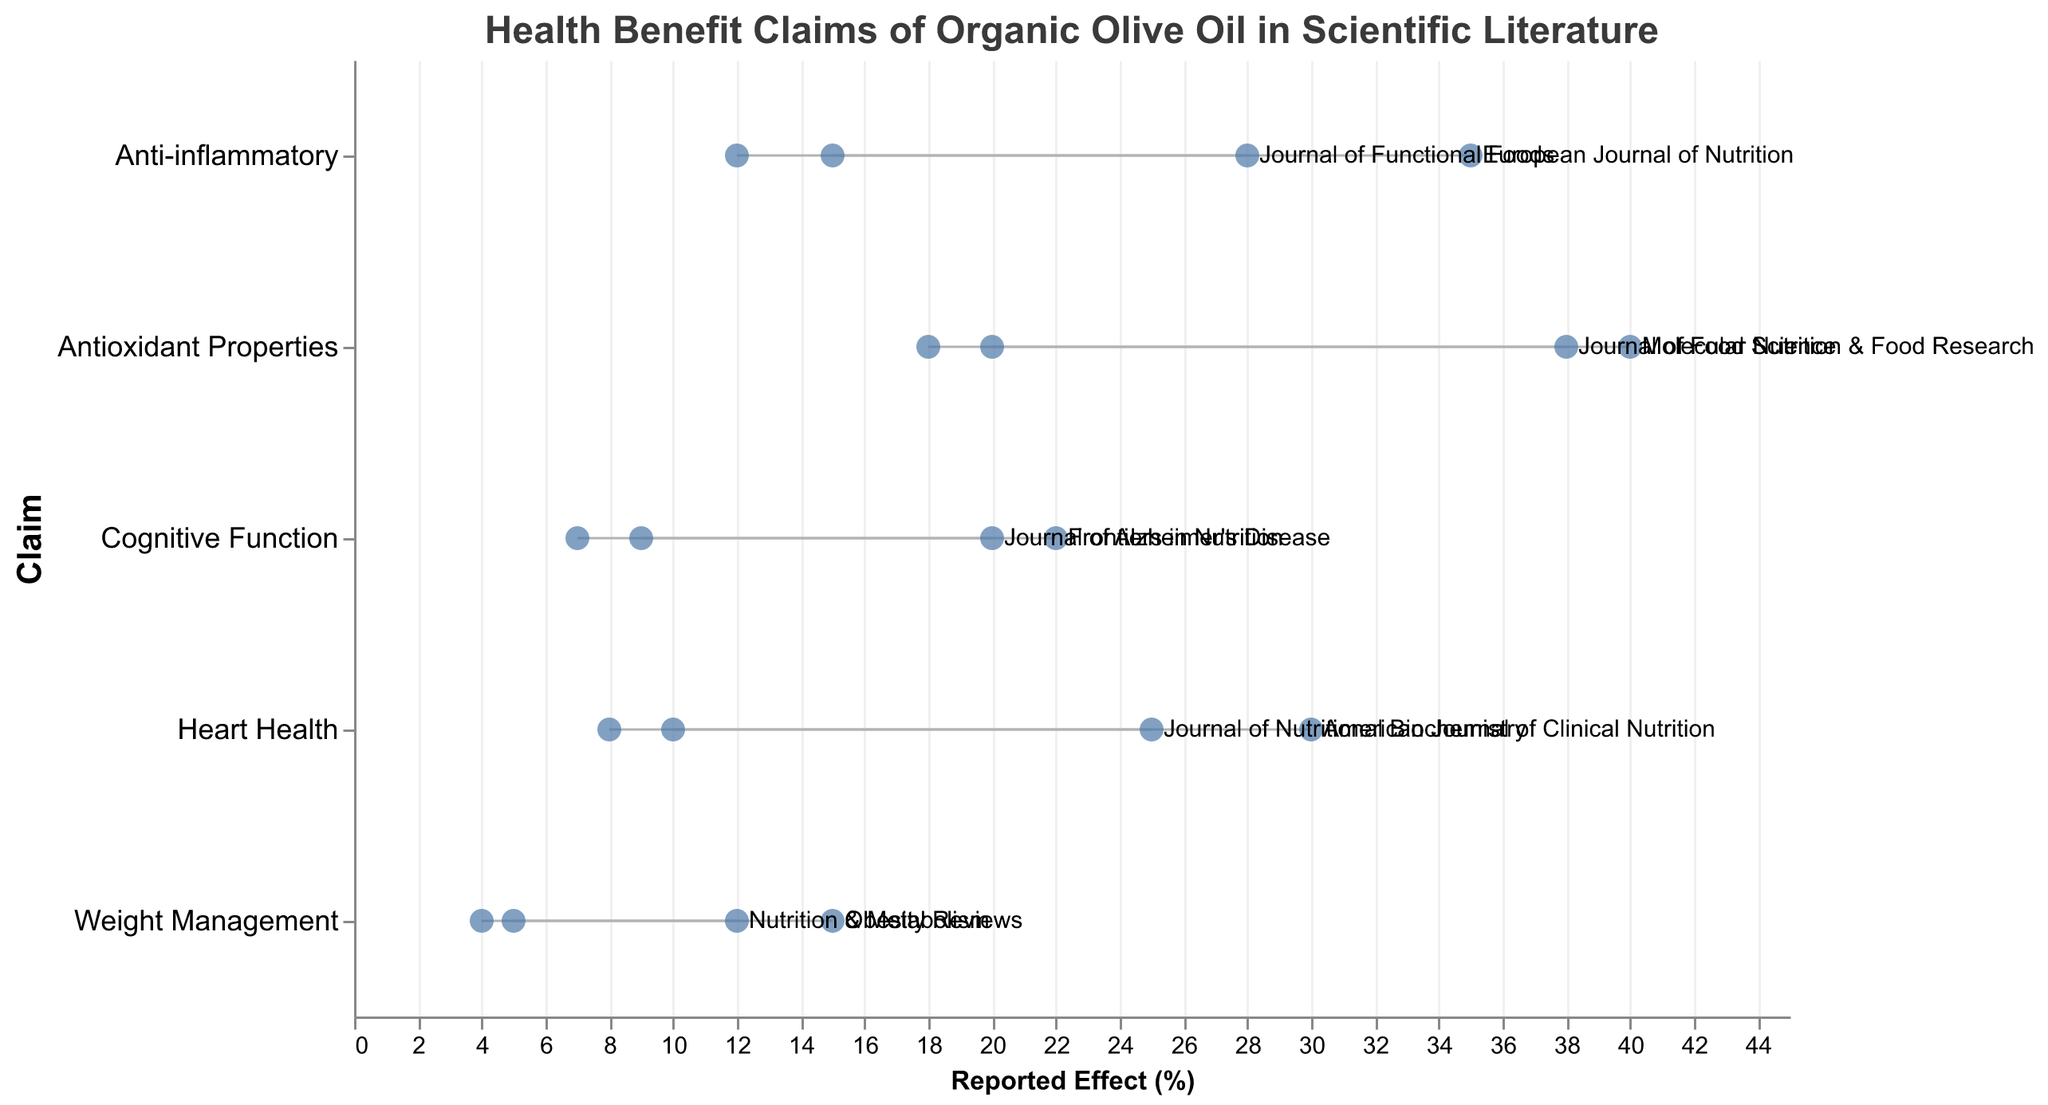What is the range of the reported effect for Heart Health in the Journal of Nutritional Biochemistry? The range can be found by looking at the minimum and maximum reported effects for Heart Health in the Journal of Nutritional Biochemistry. The min effect is 10% and the max effect is 25%.
Answer: 10%-25% Which claim shows the highest maximum reported effect? To identify the claim with the highest maximum reported effect, we need to check the maximum percentages for all claims. The highest max effect is 40% for Antioxidant Properties in Molecular Nutrition & Food Research.
Answer: Antioxidant Properties How does the range of the reported effects for Anti-inflammatory in the European Journal of Nutrition compare to that in the Journal of Functional Foods? For the European Journal of Nutrition, the range is 15%-35%. For the Journal of Functional Foods, the range is 12%-28%. By comparing these ranges, we can see that the European Journal of Nutrition has both a higher minimum and maximum reported effect.
Answer: Higher for European Journal of Nutrition Which claim has the least number of studies and what is its reported effect range? The claim with the least number of studies is Weight Management in Obesity Reviews, which has 2 studies. Its reported effect range is 5%-15%.
Answer: Weight Management, 5%-15% What is the average of the maximum reported effects for the Heart Health claim across both journals? First, sum the maximum reported effects for Heart Health, which are 25% and 30%. Then divide by the number of data points (2): (25 + 30) / 2 = 27.5%.
Answer: 27.5% For which claim is the variability (difference between min and max reported effect) the smallest, and what are the values? To find the smallest variability, we need to calculate the differences between the min and max reported effects for each claim: 
- Heart Health: 30%-8% = 22%
- Anti-inflammatory: 35%-12% = 23%
- Antioxidant Properties: 40%-18% = 22%
- Weight Management: 15%-4% = 11%
- Cognitive Function: 22%-7% = 15%
The smallest is for Weight Management with 11%.
Answer: Weight Management, 11% How many studies were conducted on Antioxidant Properties in total? To get the total, sum the number of studies from both journals reporting on Antioxidant Properties: 3 + 5 = 8 studies.
Answer: 8 What is the minimum reported effect for Cognitive Function in the Frontiers in Nutrition journal? The minimum reported effect for Cognitive Function in Frontiers in Nutrition can be directly read from the figure, which is 9%.
Answer: 9% 